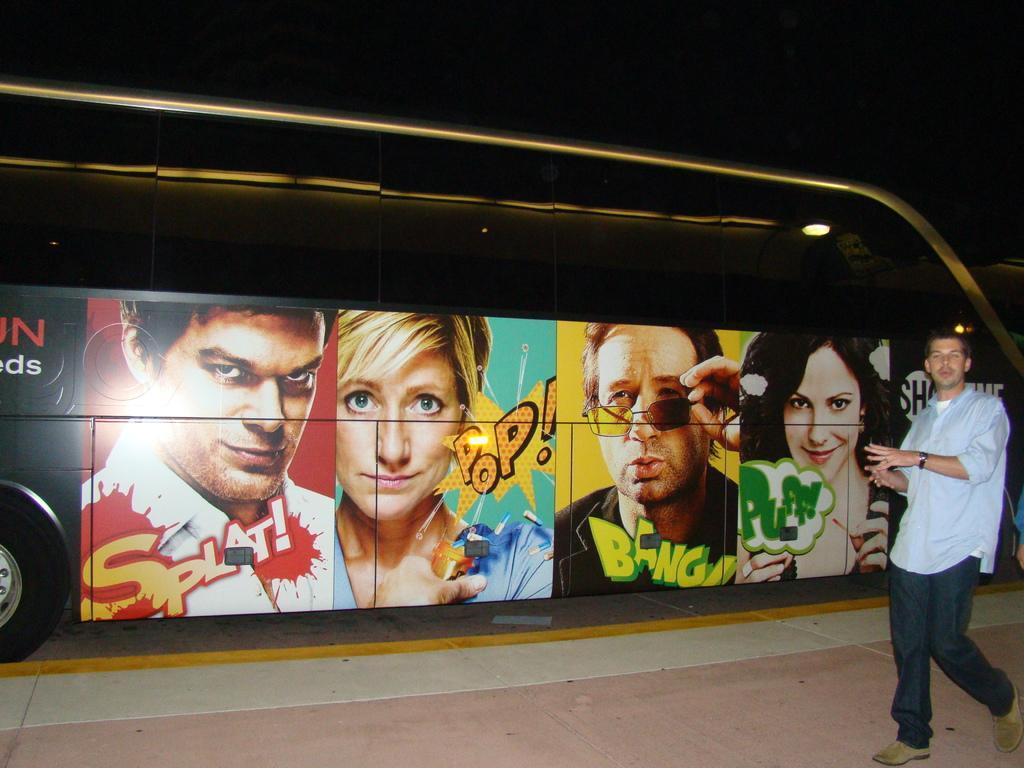How would you summarize this image in a sentence or two? In this image I can see on the right side a man is walking, he wore a shirt, trouser, shoes. In the middle there are images on the vehicle. 